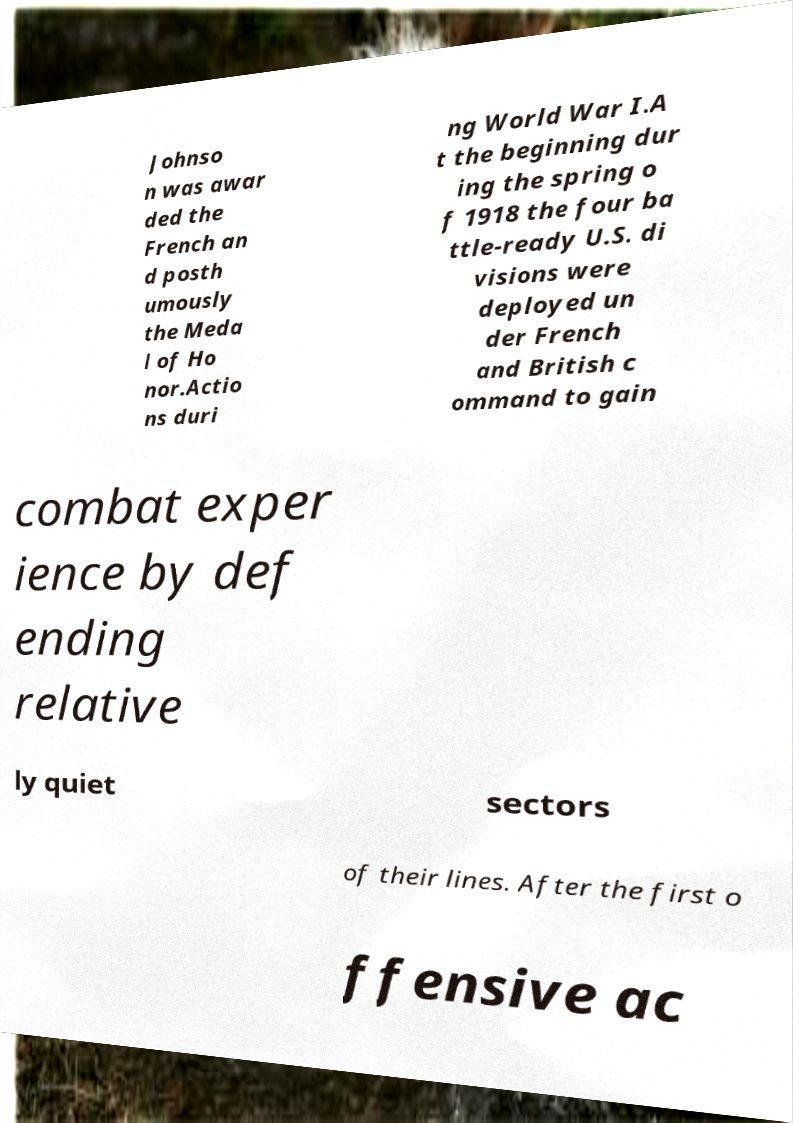Can you read and provide the text displayed in the image?This photo seems to have some interesting text. Can you extract and type it out for me? Johnso n was awar ded the French an d posth umously the Meda l of Ho nor.Actio ns duri ng World War I.A t the beginning dur ing the spring o f 1918 the four ba ttle-ready U.S. di visions were deployed un der French and British c ommand to gain combat exper ience by def ending relative ly quiet sectors of their lines. After the first o ffensive ac 